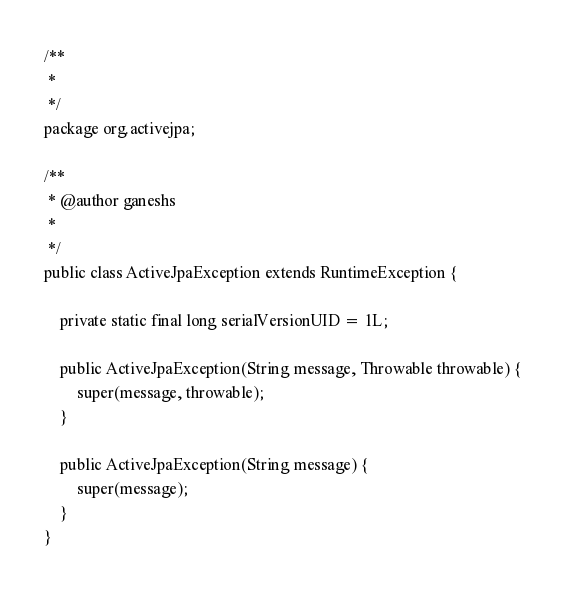<code> <loc_0><loc_0><loc_500><loc_500><_Java_>/**
 * 
 */
package org.activejpa;

/**
 * @author ganeshs
 *
 */
public class ActiveJpaException extends RuntimeException {
	
	private static final long serialVersionUID = 1L;

	public ActiveJpaException(String message, Throwable throwable) {
		super(message, throwable);
	}

	public ActiveJpaException(String message) {
		super(message);
	}
}
</code> 